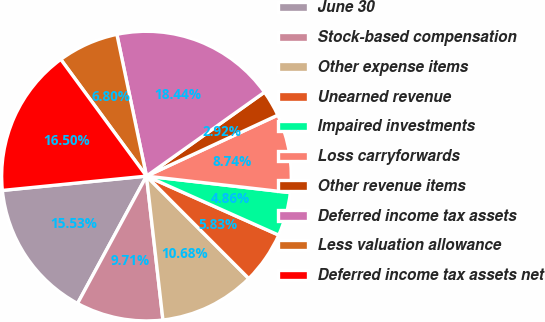Convert chart to OTSL. <chart><loc_0><loc_0><loc_500><loc_500><pie_chart><fcel>June 30<fcel>Stock-based compensation<fcel>Other expense items<fcel>Unearned revenue<fcel>Impaired investments<fcel>Loss carryforwards<fcel>Other revenue items<fcel>Deferred income tax assets<fcel>Less valuation allowance<fcel>Deferred income tax assets net<nl><fcel>15.53%<fcel>9.71%<fcel>10.68%<fcel>5.83%<fcel>4.86%<fcel>8.74%<fcel>2.92%<fcel>18.44%<fcel>6.8%<fcel>16.5%<nl></chart> 